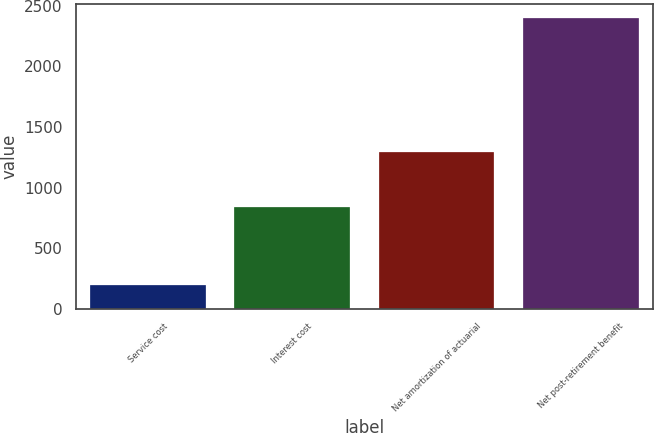Convert chart. <chart><loc_0><loc_0><loc_500><loc_500><bar_chart><fcel>Service cost<fcel>Interest cost<fcel>Net amortization of actuarial<fcel>Net post-retirement benefit<nl><fcel>198<fcel>843<fcel>1291<fcel>2394<nl></chart> 